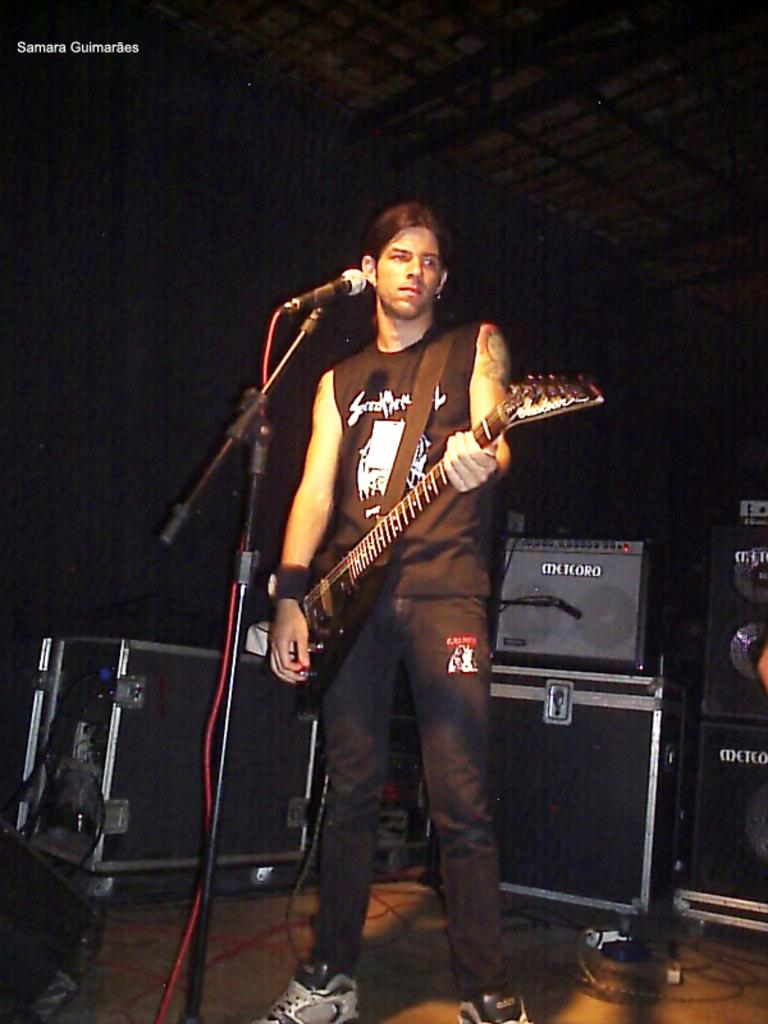What is the main subject of the image? The main subject of the image is a man. What is the man doing in the image? The man is standing in the image. What object is the man holding in the image? The man is holding a guitar in the image. What type of clothing is the man wearing on his upper body? The man is wearing a t-shirt in the image. What type of clothing is the man wearing on his lower body? The man is wearing pants in the image. What type of footwear is the man wearing in the image? The man is wearing shoes in the image. What object is in front of the man in the image? There is a microphone in front of the man in the image. What objects are behind the man in the image? There are speakers behind the man in the image. How many zippers can be seen on the man's t-shirt in the image? There are no zippers visible on the man's t-shirt in the image. What type of slip is the man wearing under his pants in the image? The man is not wearing a slip under his pants in the image. How many clocks are visible in the image? There are no clocks visible in the image. 